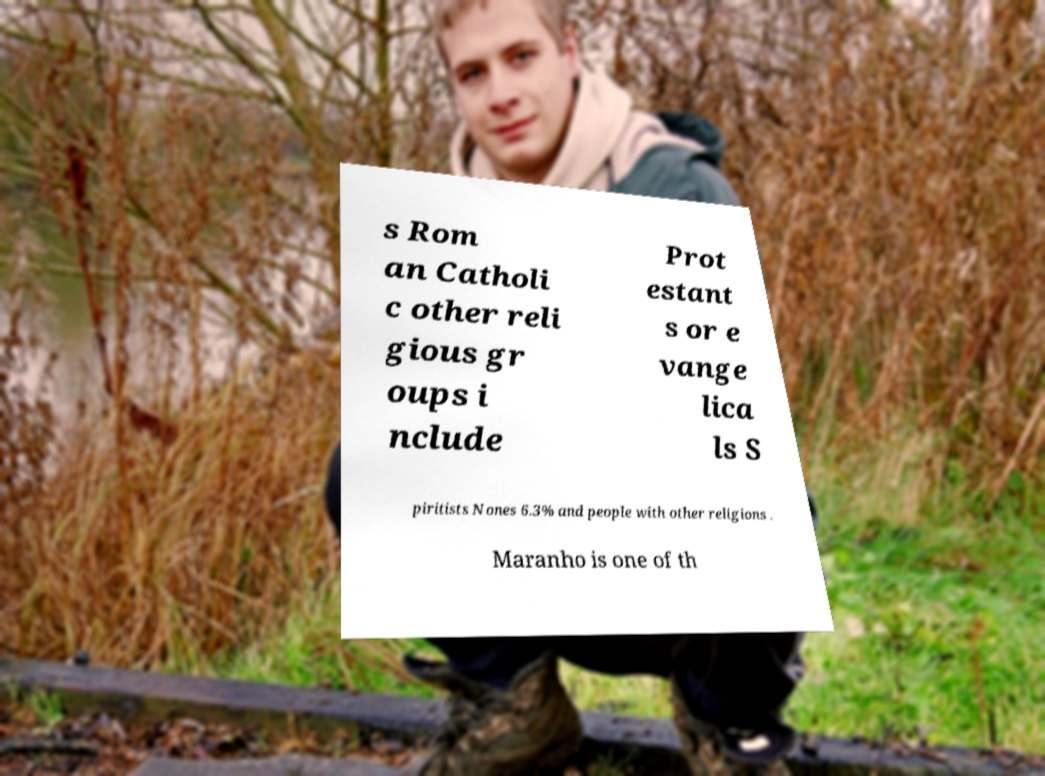What messages or text are displayed in this image? I need them in a readable, typed format. s Rom an Catholi c other reli gious gr oups i nclude Prot estant s or e vange lica ls S piritists Nones 6.3% and people with other religions . Maranho is one of th 